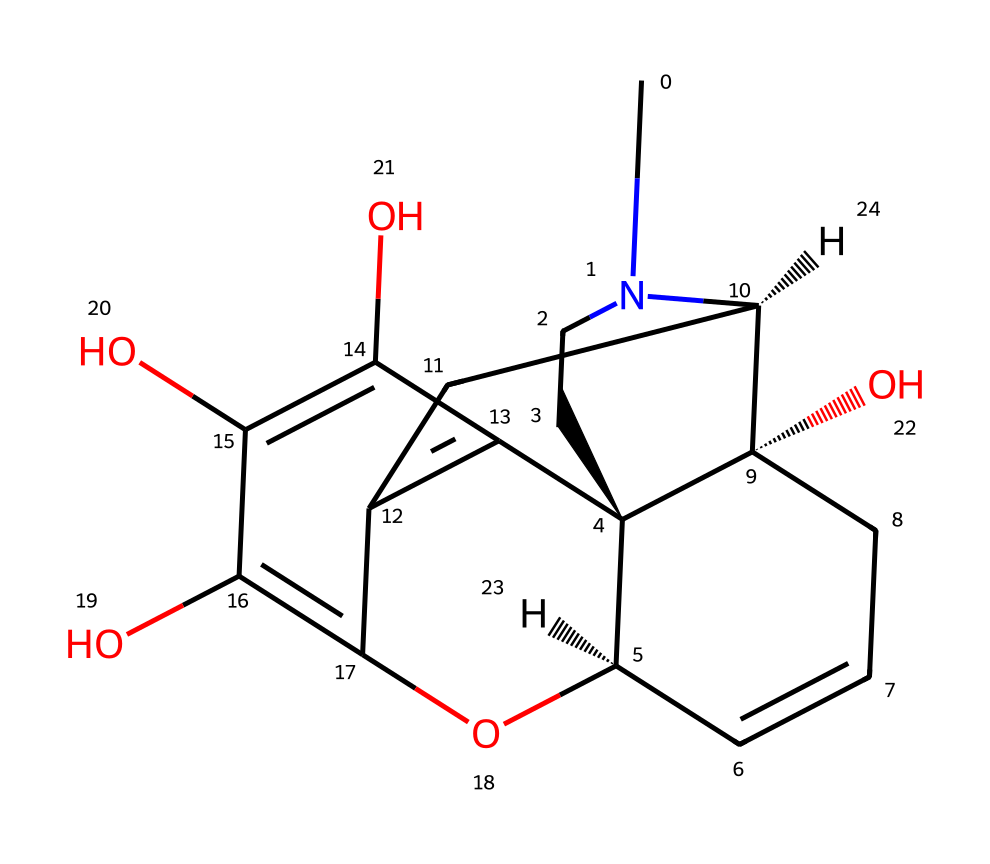What is the primary functional group in morphine? The primary functional group in morphine is the hydroxyl group (-OH), which is crucial for its pharmacological activity. The presence of multiple hydroxyl groups on the phenolic rings contributes to its binding to opioid receptors.
Answer: hydroxyl group How many chiral centers are present in morphine? In analyzing the chemical structure, we can identify four carbon atoms that are bonded to four different substituents, confirming the presence of four chiral centers in the molecule.
Answer: four What is the molecular formula of morphine? By counting the atoms represented in the structure using the SMILES notation, the molecular formula can be determined to consist of 17 carbons, 19 hydrogens, and 3 nitrogens, leading to the formula C17H19N3O3.
Answer: C17H19N3O3 Which part of the morphine structure is responsible for its analgesic properties? The phenolic hydroxyl groups and the piperidine ring in morphine facilitate its binding to the μ-opioid receptor, critical for its pain-relieving (analgesic) properties, enhancing its efficacy as a drug.
Answer: piperidine ring and phenolic hydroxyl groups What type of drug is morphine classified as? Morphine is classified as an opioid, which is characterized by its efficacy in pain management through interactions with opioid receptors in the brain and body.
Answer: opioid 